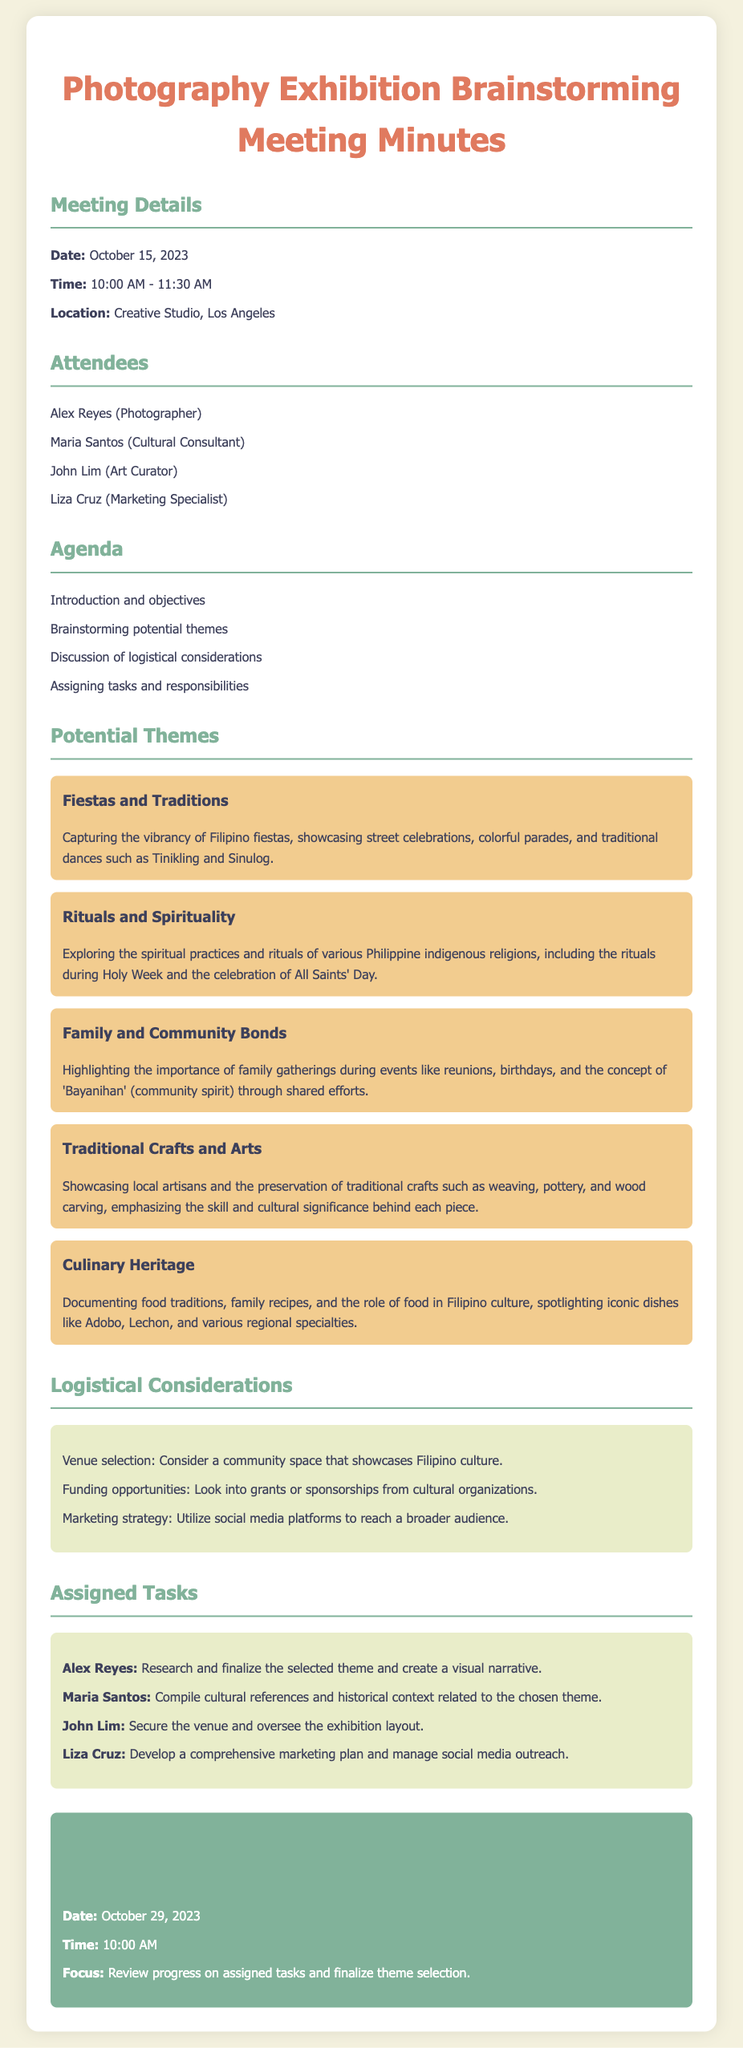What is the date of the meeting? The meeting date is explicitly stated in the document under Meeting Details.
Answer: October 15, 2023 Who is the marketing specialist? The attendee list mentions the roles of each attendee, including the marketing specialist.
Answer: Liza Cruz What is one theme discussed during the brainstorming session? The document lists several potential themes, showcasing various aspects of Filipino culture.
Answer: Fiestas and Traditions What time is the next meeting scheduled for? The time for the next meeting is detailed in the Next Meeting section.
Answer: 10:00 AM What task is assigned to Alex Reyes? The Assigned Tasks section specifies individual responsibilities, including what is assigned to Alex Reyes.
Answer: Research and finalize the selected theme and create a visual narrative How many themes are listed in total? By counting the distinct themes presented in the Potential Themes section, the total can be determined.
Answer: Five What is the purpose of the next meeting? The focus of the next meeting is mentioned directly in the Next Meeting section.
Answer: Review progress on assigned tasks and finalize theme selection Which specific Filipino dish is mentioned under Culinary Heritage? The document provides an example of a Filipino dish in the Culinary Heritage theme description.
Answer: Adobo 